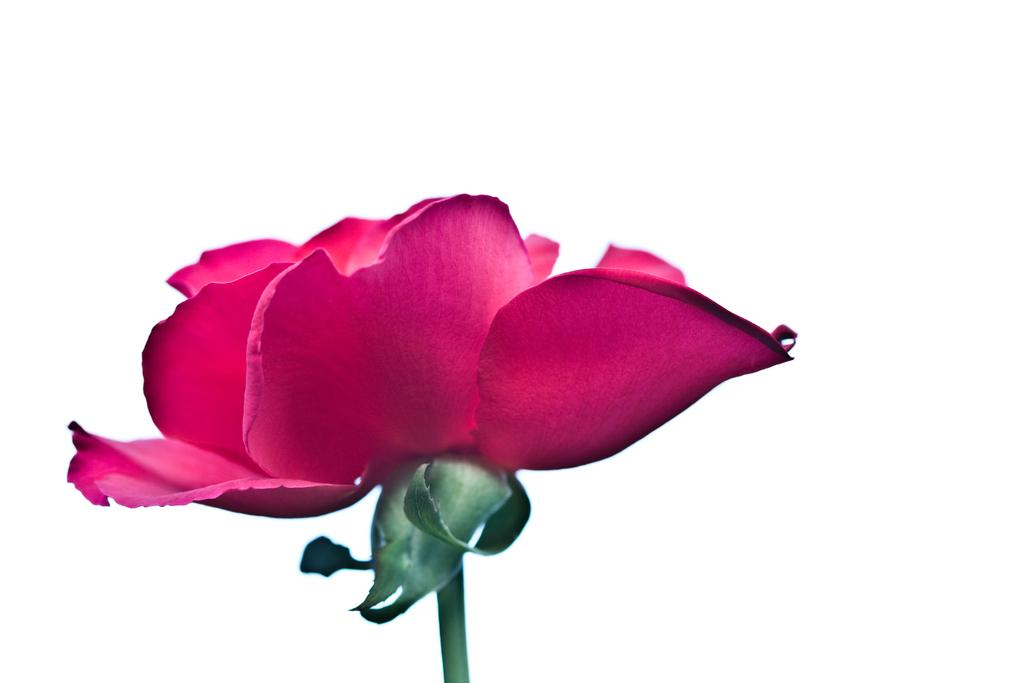What type of flower is in the image? There is a rose flower in the image. What color is the rose flower? The rose flower is pink in color. Where is the rose flower located in the image? The rose flower is located in the middle of the image. What type of skirt is worn by the rose flower in the image? There is no skirt present in the image, as the subject is a rose flower. 